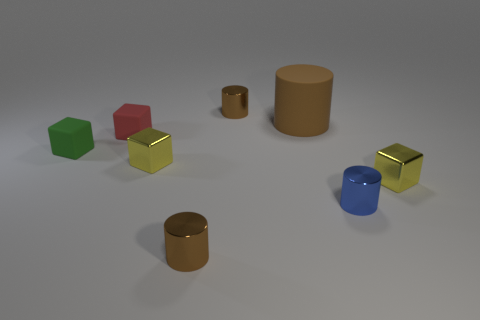There is a brown object to the right of the small brown metal cylinder behind the tiny rubber thing that is behind the green rubber object; what is its size?
Provide a short and direct response. Large. There is a green object that is behind the brown metallic cylinder that is on the left side of the tiny brown object that is behind the big rubber thing; what is it made of?
Provide a short and direct response. Rubber. Does the big brown rubber thing have the same shape as the small blue thing?
Ensure brevity in your answer.  Yes. What number of tiny metallic cylinders are in front of the large brown object and on the left side of the big rubber cylinder?
Your response must be concise. 1. What is the color of the shiny cube to the left of the brown cylinder in front of the blue shiny cylinder?
Offer a terse response. Yellow. Are there an equal number of things in front of the tiny blue object and big cyan metallic cubes?
Keep it short and to the point. No. There is a tiny metal block in front of the yellow object on the left side of the blue metal cylinder; what number of cubes are left of it?
Your response must be concise. 3. The metallic cylinder that is behind the small blue cylinder is what color?
Provide a short and direct response. Brown. There is a object that is both behind the green block and in front of the big cylinder; what is its material?
Make the answer very short. Rubber. What number of things are right of the small matte object that is behind the green rubber block?
Provide a succinct answer. 6. 